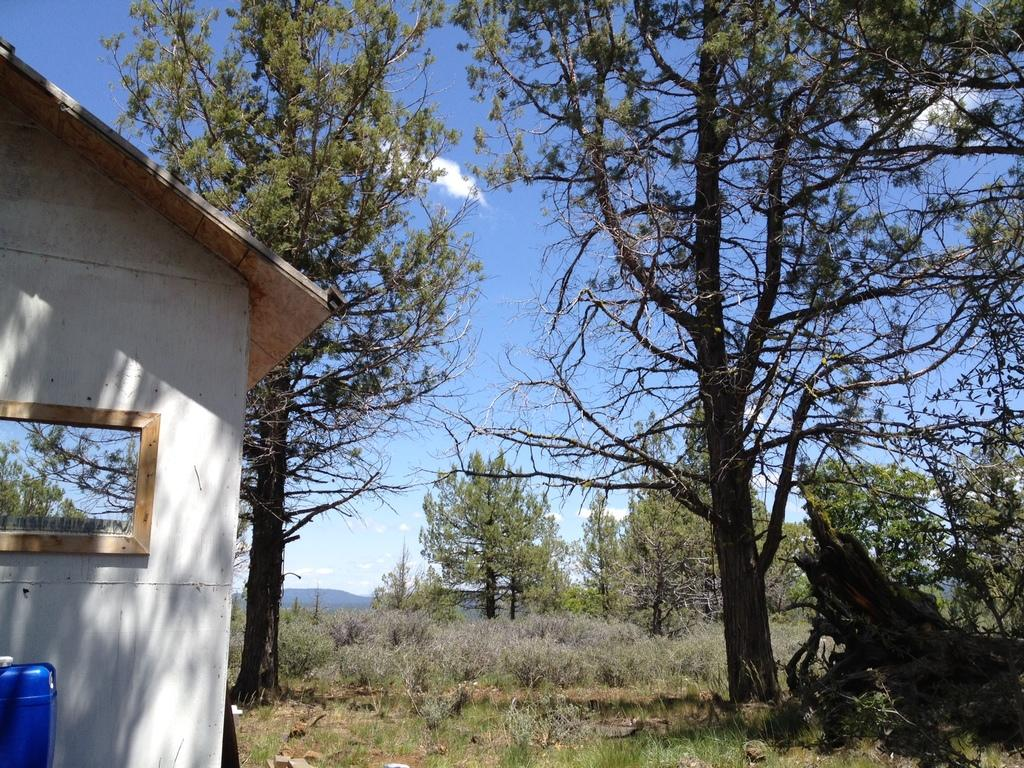What type of structure is present in the image? There is a house in the image. What object can be used for personal grooming or reflection? There is a mirror in the image. What type of vegetation is present in the image? There are trees and grass in the image. What can be seen in the background of the image? The sky with clouds is visible in the background of the image. How many balls are visible in the image? There are no balls present in the image. What type of skin is visible on the trees in the image? Trees do not have skin; they have bark. 